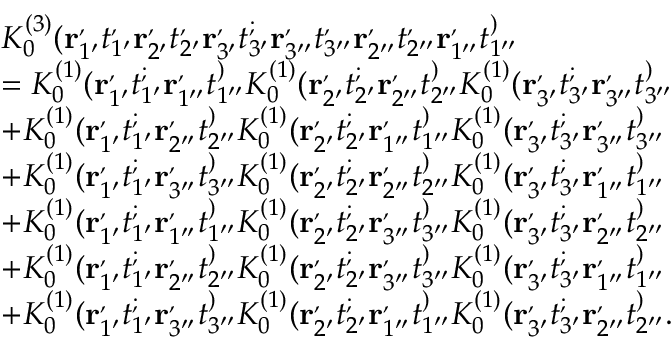Convert formula to latex. <formula><loc_0><loc_0><loc_500><loc_500>\begin{array} { r l } & { K _ { 0 } ^ { ( 3 ) } ( r _ { 1 ^ { \prime } } ^ { , } t _ { 1 ^ { \prime } } ^ { , } r _ { 2 ^ { \prime } } ^ { , } t _ { 2 ^ { \prime } } ^ { , } r _ { 3 ^ { \prime } } ^ { , } t _ { 3 ^ { \prime } } ^ { ; } r _ { 3 ^ { \prime \prime } } ^ { , } t _ { 3 ^ { \prime \prime } } ^ { , } r _ { 2 ^ { \prime \prime } } ^ { , } t _ { 2 ^ { \prime \prime } } ^ { , } r _ { 1 ^ { \prime \prime } } ^ { , } t _ { 1 ^ { \prime \prime } } ^ { ) } } \\ & { = K _ { 0 } ^ { ( 1 ) } ( r _ { 1 ^ { \prime } } ^ { , } t _ { 1 ^ { \prime } } ^ { ; } r _ { 1 ^ { \prime \prime } } ^ { , } t _ { 1 ^ { \prime \prime } } ^ { ) } K _ { 0 } ^ { ( 1 ) } ( r _ { 2 ^ { \prime } } ^ { , } t _ { 2 ^ { \prime } } ^ { ; } r _ { 2 ^ { \prime \prime } } ^ { , } t _ { 2 ^ { \prime \prime } } ^ { ) } K _ { 0 } ^ { ( 1 ) } ( r _ { 3 ^ { \prime } } ^ { , } t _ { 3 ^ { \prime } } ^ { ; } r _ { 3 ^ { \prime \prime } } ^ { , } t _ { 3 ^ { \prime \prime } } ^ { ) } } \\ & { + K _ { 0 } ^ { ( 1 ) } ( r _ { 1 ^ { \prime } } ^ { , } t _ { 1 ^ { \prime } } ^ { ; } r _ { 2 ^ { \prime \prime } } ^ { , } t _ { 2 ^ { \prime \prime } } ^ { ) } K _ { 0 } ^ { ( 1 ) } ( r _ { 2 ^ { \prime } } ^ { , } t _ { 2 ^ { \prime } } ^ { ; } r _ { 1 ^ { \prime \prime } } ^ { , } t _ { 1 ^ { \prime \prime } } ^ { ) } K _ { 0 } ^ { ( 1 ) } ( r _ { 3 ^ { \prime } } ^ { , } t _ { 3 ^ { \prime } } ^ { ; } r _ { 3 ^ { \prime \prime } } ^ { , } t _ { 3 ^ { \prime \prime } } ^ { ) } } \\ & { + K _ { 0 } ^ { ( 1 ) } ( r _ { 1 ^ { \prime } } ^ { , } t _ { 1 ^ { \prime } } ^ { ; } r _ { 3 ^ { \prime \prime } } ^ { , } t _ { 3 ^ { \prime \prime } } ^ { ) } K _ { 0 } ^ { ( 1 ) } ( r _ { 2 ^ { \prime } } ^ { , } t _ { 2 ^ { \prime } } ^ { ; } r _ { 2 ^ { \prime \prime } } ^ { , } t _ { 2 ^ { \prime \prime } } ^ { ) } K _ { 0 } ^ { ( 1 ) } ( r _ { 3 ^ { \prime } } ^ { , } t _ { 3 ^ { \prime } } ^ { ; } r _ { 1 ^ { \prime \prime } } ^ { , } t _ { 1 ^ { \prime \prime } } ^ { ) } } \\ & { + K _ { 0 } ^ { ( 1 ) } ( r _ { 1 ^ { \prime } } ^ { , } t _ { 1 ^ { \prime } } ^ { ; } r _ { 1 ^ { \prime \prime } } ^ { , } t _ { 1 ^ { \prime \prime } } ^ { ) } K _ { 0 } ^ { ( 1 ) } ( r _ { 2 ^ { \prime } } ^ { , } t _ { 2 ^ { \prime } } ^ { ; } r _ { 3 ^ { \prime \prime } } ^ { , } t _ { 3 ^ { \prime \prime } } ^ { ) } K _ { 0 } ^ { ( 1 ) } ( r _ { 3 ^ { \prime } } ^ { , } t _ { 3 ^ { \prime } } ^ { ; } r _ { 2 ^ { \prime \prime } } ^ { , } t _ { 2 ^ { \prime \prime } } ^ { ) } } \\ & { + K _ { 0 } ^ { ( 1 ) } ( r _ { 1 ^ { \prime } } ^ { , } t _ { 1 ^ { \prime } } ^ { ; } r _ { 2 ^ { \prime \prime } } ^ { , } t _ { 2 ^ { \prime \prime } } ^ { ) } K _ { 0 } ^ { ( 1 ) } ( r _ { 2 ^ { \prime } } ^ { , } t _ { 2 ^ { \prime } } ^ { ; } r _ { 3 ^ { \prime \prime } } ^ { , } t _ { 3 ^ { \prime \prime } } ^ { ) } K _ { 0 } ^ { ( 1 ) } ( r _ { 3 ^ { \prime } } ^ { , } t _ { 3 ^ { \prime } } ^ { ; } r _ { 1 ^ { \prime \prime } } ^ { , } t _ { 1 ^ { \prime \prime } } ^ { ) } } \\ & { + K _ { 0 } ^ { ( 1 ) } ( r _ { 1 ^ { \prime } } ^ { , } t _ { 1 ^ { \prime } } ^ { ; } r _ { 3 ^ { \prime \prime } } ^ { , } t _ { 3 ^ { \prime \prime } } ^ { ) } K _ { 0 } ^ { ( 1 ) } ( r _ { 2 ^ { \prime } } ^ { , } t _ { 2 ^ { \prime } } ^ { ; } r _ { 1 ^ { \prime \prime } } ^ { , } t _ { 1 ^ { \prime \prime } } ^ { ) } K _ { 0 } ^ { ( 1 ) } ( r _ { 3 ^ { \prime } } ^ { , } t _ { 3 ^ { \prime } } ^ { ; } r _ { 2 ^ { \prime \prime } } ^ { , } t _ { 2 ^ { \prime \prime } } ^ { ) } . } \end{array}</formula> 